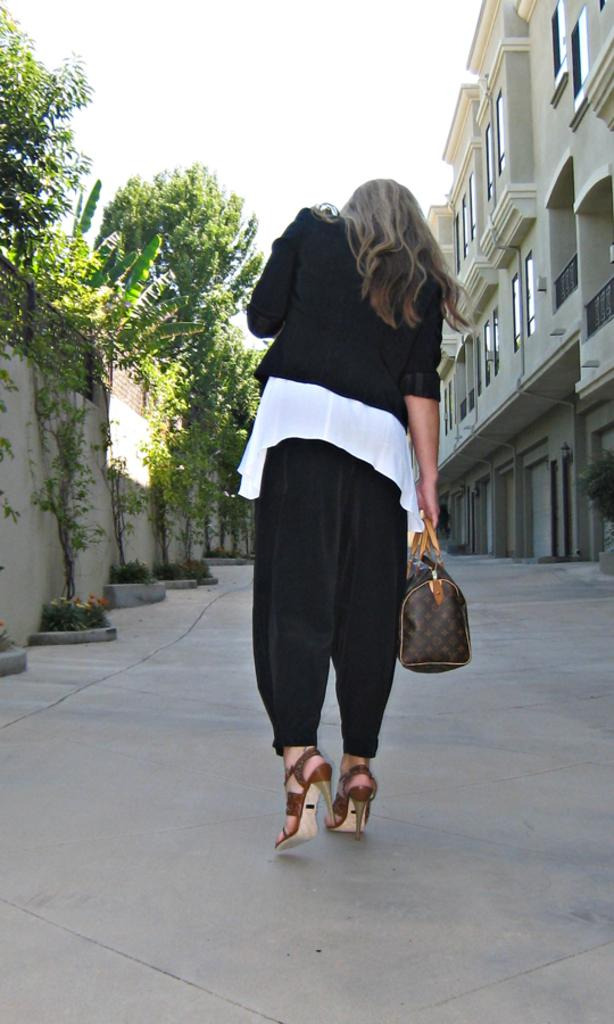Where is the person in the image located? The person in the image is standing outside of the city. What is the person holding in the image? The person is holding a handbag. What type of clothing is the person wearing? The person is wearing a black jacket. What can be seen in the background of the image? There are trees, the sky, and buildings visible in the background of the image. Can you see a snake slithering across the bridge in the image? There is no snake or bridge present in the image. What is the reason the person is standing outside of the city in the image? The image does not provide any information about the person's reason for standing outside of the city. 